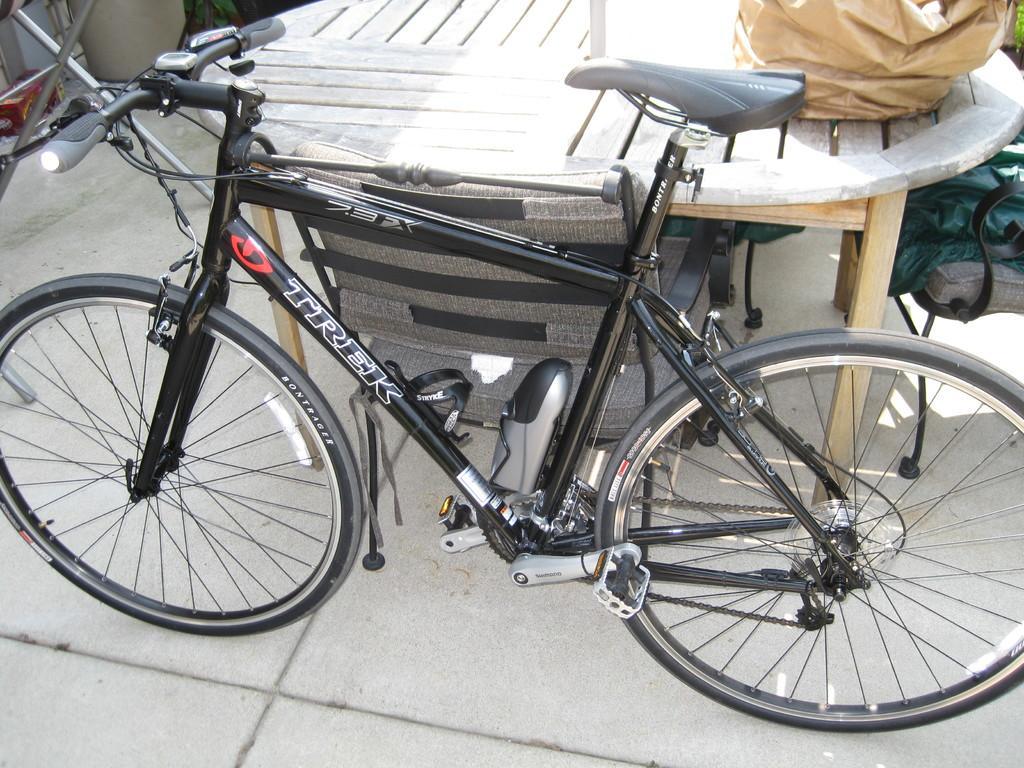In one or two sentences, can you explain what this image depicts? In this image there is a table with some chairs around and bicycle parked beside that, also there are some covers on the table. 